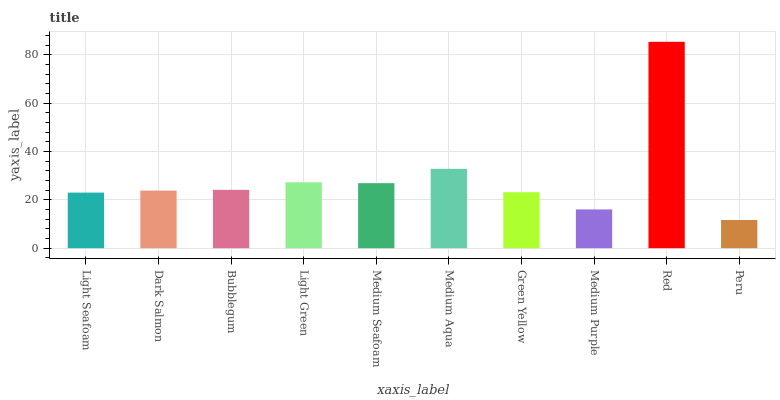Is Peru the minimum?
Answer yes or no. Yes. Is Red the maximum?
Answer yes or no. Yes. Is Dark Salmon the minimum?
Answer yes or no. No. Is Dark Salmon the maximum?
Answer yes or no. No. Is Dark Salmon greater than Light Seafoam?
Answer yes or no. Yes. Is Light Seafoam less than Dark Salmon?
Answer yes or no. Yes. Is Light Seafoam greater than Dark Salmon?
Answer yes or no. No. Is Dark Salmon less than Light Seafoam?
Answer yes or no. No. Is Bubblegum the high median?
Answer yes or no. Yes. Is Dark Salmon the low median?
Answer yes or no. Yes. Is Medium Seafoam the high median?
Answer yes or no. No. Is Medium Purple the low median?
Answer yes or no. No. 